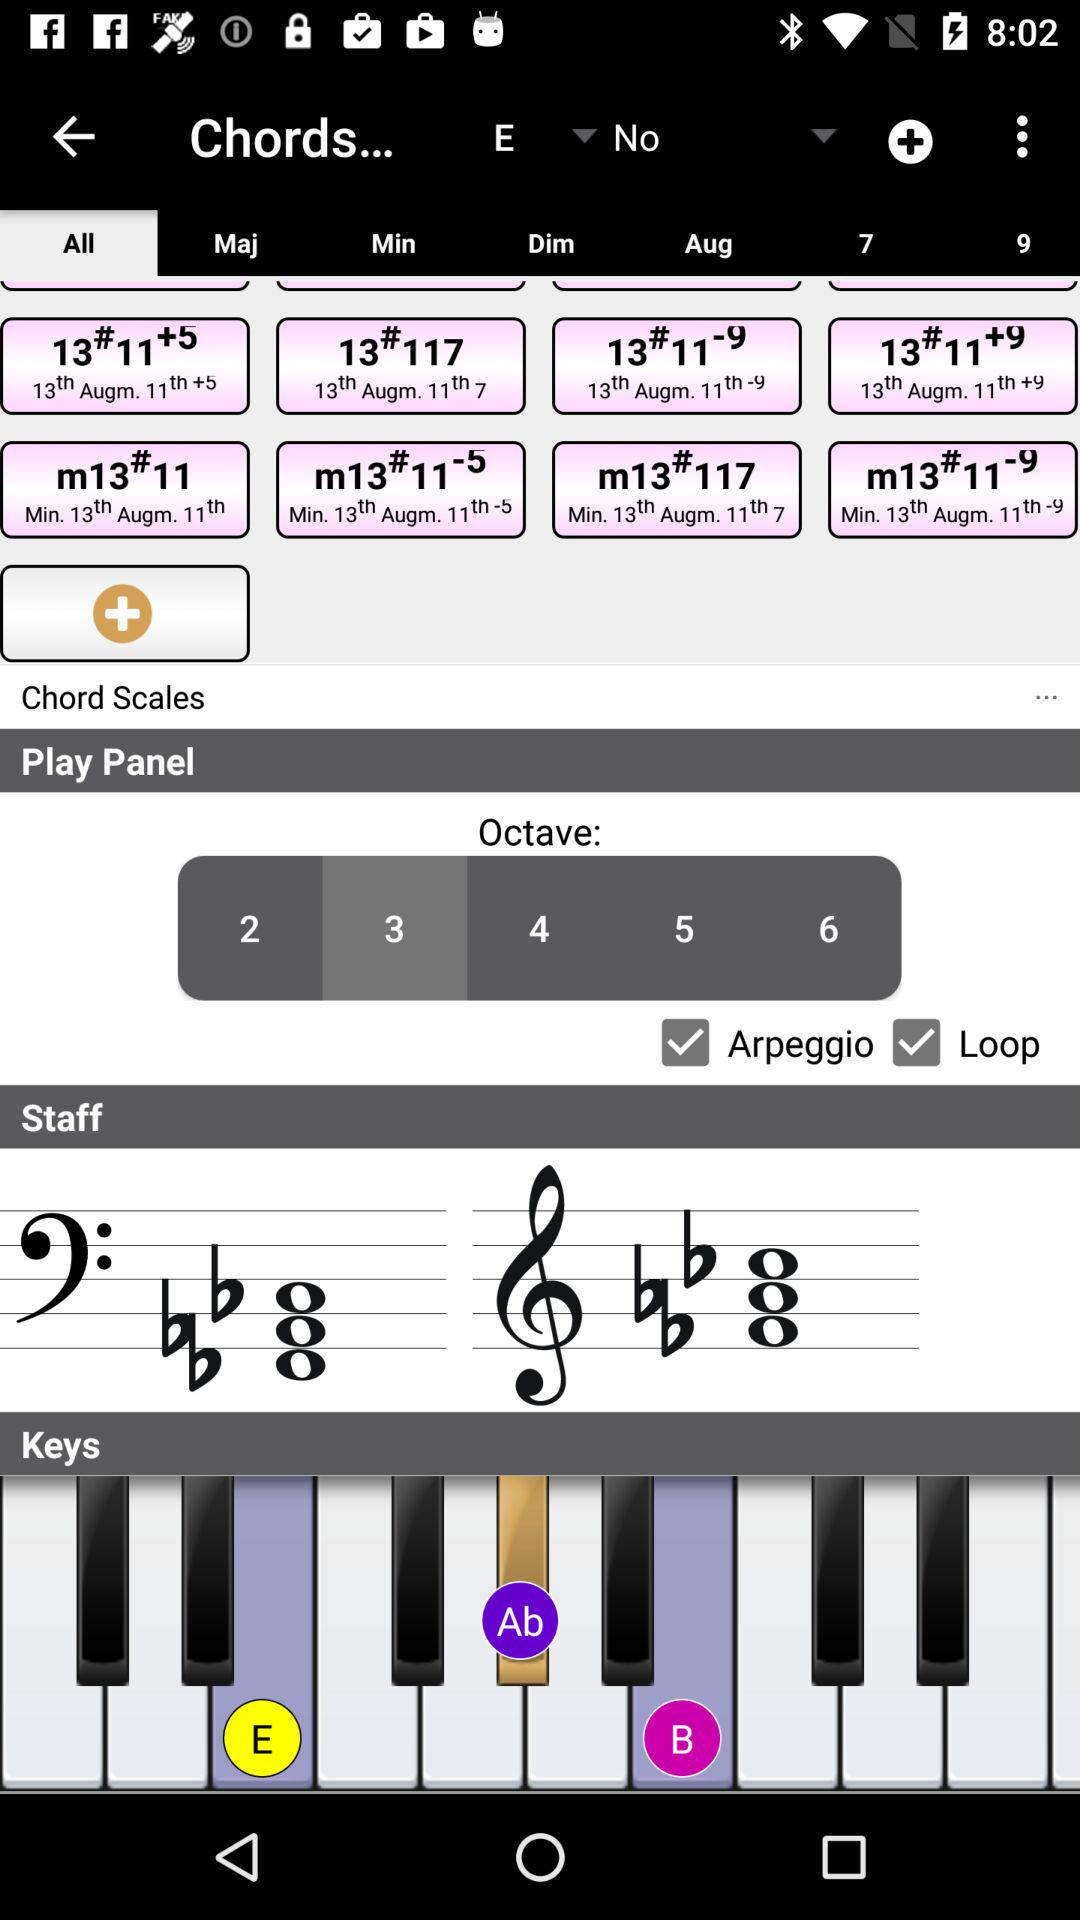What is the selected tab? The selected tab is "All". 